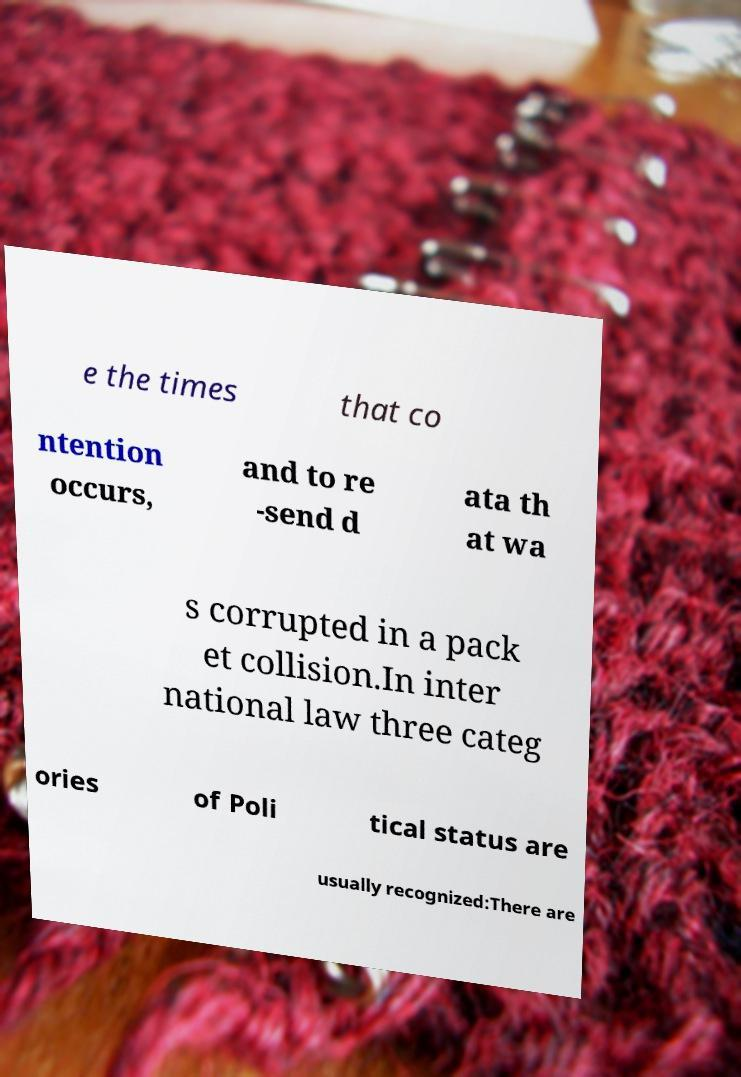Please identify and transcribe the text found in this image. e the times that co ntention occurs, and to re -send d ata th at wa s corrupted in a pack et collision.In inter national law three categ ories of Poli tical status are usually recognized:There are 